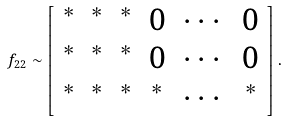Convert formula to latex. <formula><loc_0><loc_0><loc_500><loc_500>\ f _ { 2 2 } \sim \left [ \begin{array} { c c c c c c } ^ { * } & ^ { * } & ^ { * } & 0 & \cdots & 0 \\ ^ { * } & ^ { * } & ^ { * } & 0 & \cdots & 0 \\ ^ { * } & ^ { * } & ^ { * } & ^ { * } & \cdots & ^ { * } \end{array} \right ] .</formula> 